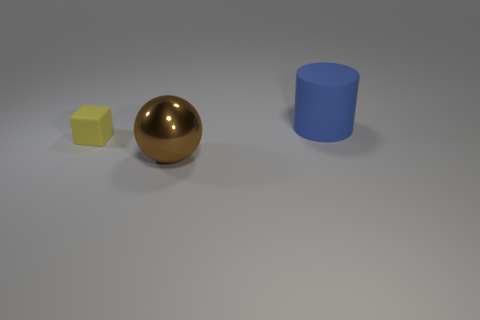Is there any other thing that is the same size as the yellow rubber block?
Provide a short and direct response. No. Is there anything else that has the same material as the brown object?
Your answer should be very brief. No. What number of other objects are there of the same shape as the tiny thing?
Ensure brevity in your answer.  0. What color is the thing that is both behind the brown thing and on the right side of the block?
Ensure brevity in your answer.  Blue. How many small things are either brown things or yellow blocks?
Keep it short and to the point. 1. Is there anything else of the same color as the shiny sphere?
Provide a succinct answer. No. What is the material of the object that is on the right side of the big thing in front of the matte object that is to the right of the big brown thing?
Provide a short and direct response. Rubber. What number of metallic objects are big brown spheres or tiny objects?
Ensure brevity in your answer.  1. How many brown things are cylinders or balls?
Your answer should be very brief. 1. Is the large cylinder made of the same material as the sphere?
Offer a very short reply. No. 